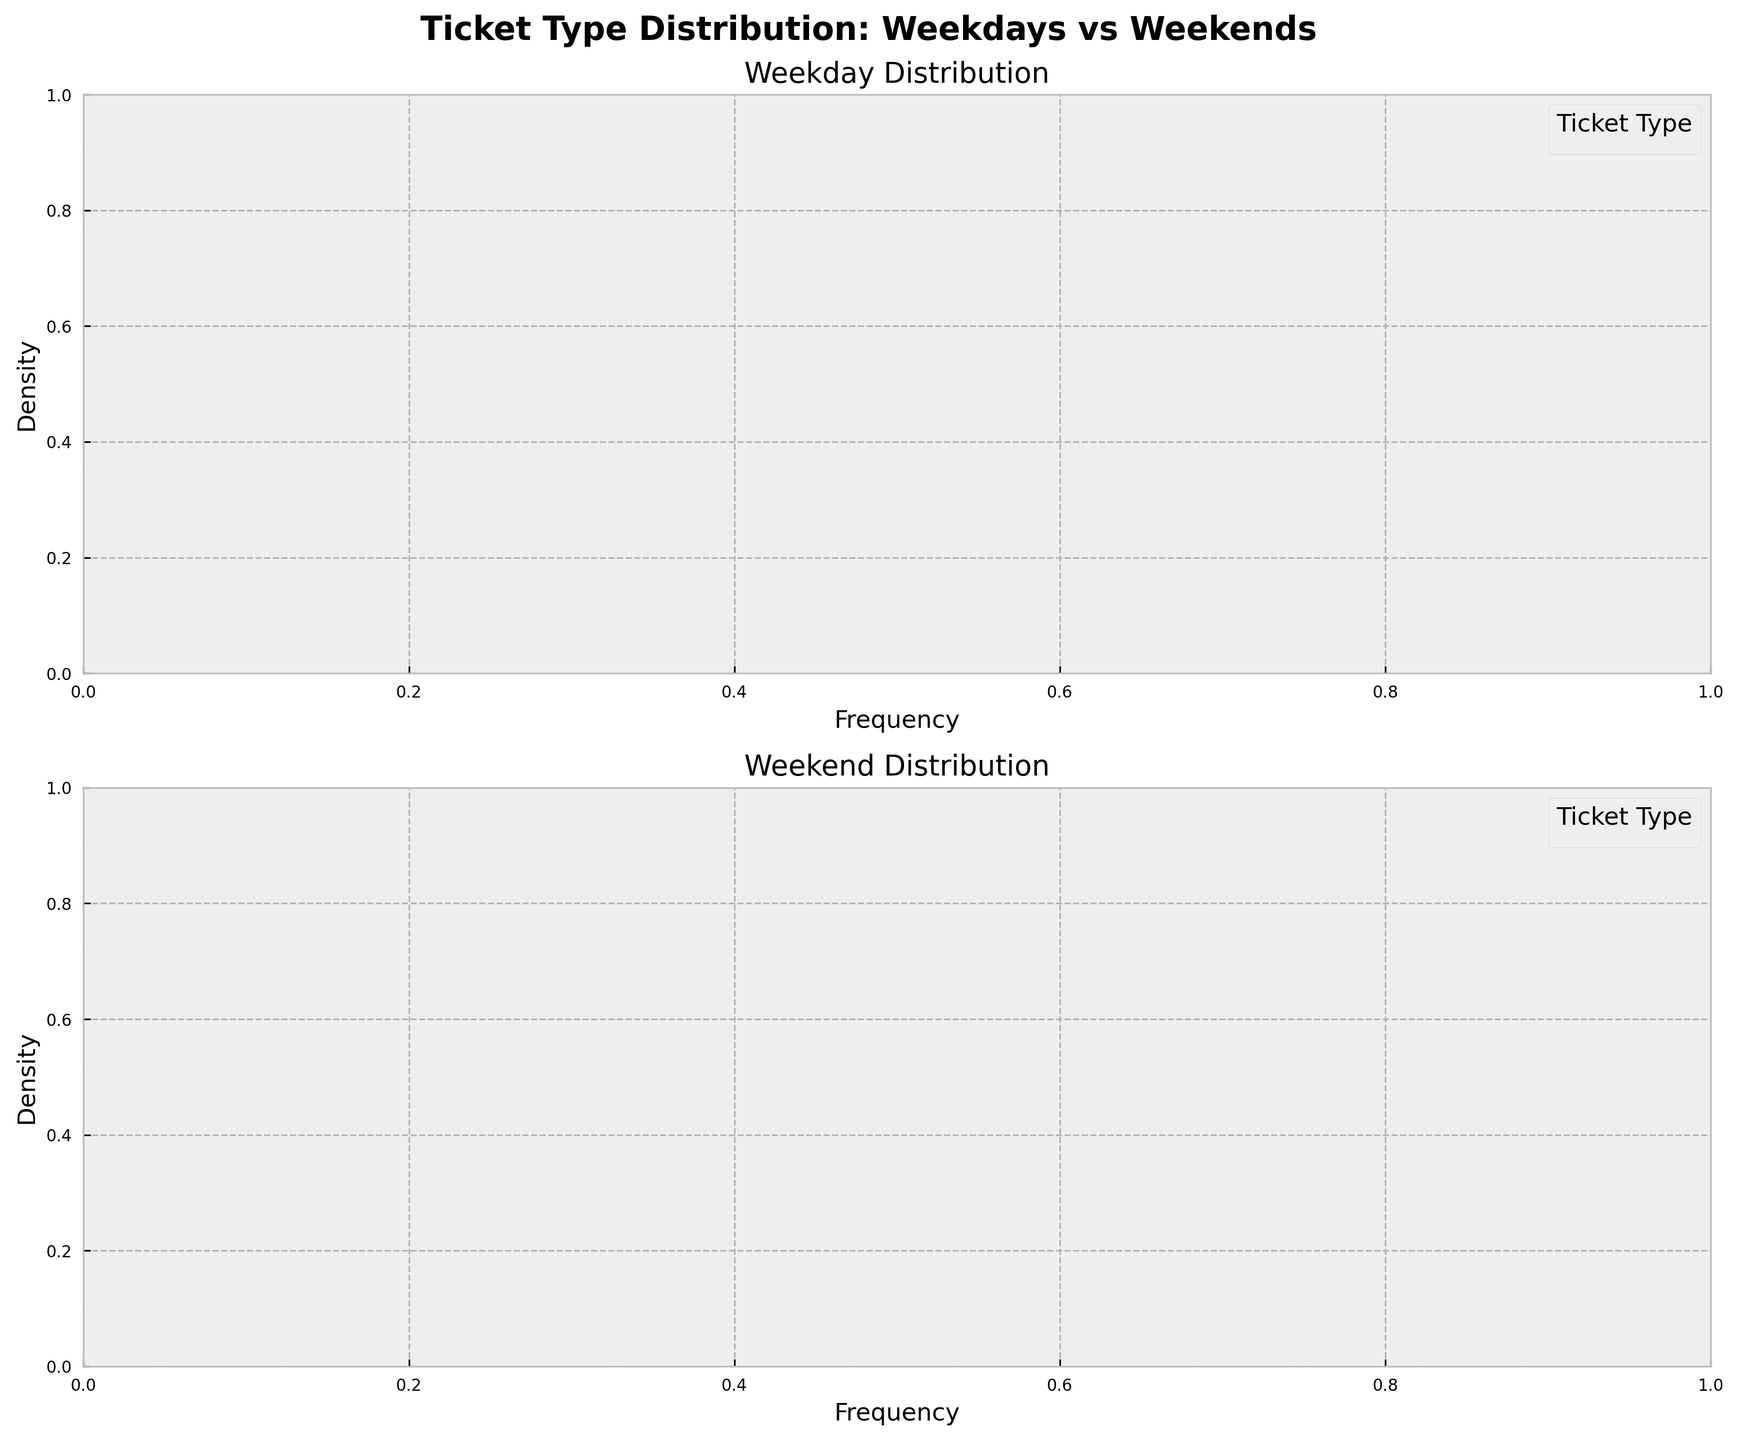What is the title of the figure? The title is displayed at the top of the figure. It reads 'Ticket Type Distribution: Weekdays vs Weekends'.
Answer: Ticket Type Distribution: Weekdays vs Weekends What is the x-axis label of the weekday subplot? The x-axis label is located below the x-axis in the weekday distribution subplot. It reads 'Frequency'.
Answer: Frequency Which ticket type shows the highest frequency density on weekends? By examining the density curves in the weekend subplot, we can see which ticket type has the highest peak. The 'Single' ticket type has the highest peak.
Answer: Single How does the density of Senior Citizen tickets compare between weekdays and weekends? Look at the density curves for 'Senior Citizen' tickets in both subplots. On weekends, the density for 'Senior Citizen' tickets is higher compared to weekdays.
Answer: Weekends have higher density Is the distribution of 'Off-Peak' ticket sales more spread out on weekdays or weekends? By comparing the width and shape of the 'Off-Peak' density curves in both subplots, we find that the weekend distribution is more spread out.
Answer: Weekends Which day shows a greater density for 'Student Pass' tickets? Compare the height of the 'Student Pass' ticket density curves in both subplots. The weekday subplot has a higher peak.
Answer: Weekdays How does the distribution of 'Family Day Pass' tickets differ between weekdays and weekends? Examine the shape and height of the 'Family Day Pass' density curves. On weekends, the density is higher and has a sharper peak compared to the wider and lower peak on weekdays.
Answer: Weekends have higher density and a sharper peak Which ticket type has a noticeably greater density on weekdays compared to weekends? By comparing all the density curves in both subplots, 'Return' tickets and 'Student Pass' have noticeably greater density on weekdays.
Answer: Return and Student Pass In terms of frequency distribution, which ticket type on weekends has a similar pattern to 'Single' tickets on weekdays? By comparing the shape and height of the curves, 'Off-Peak' tickets on weekends show a somewhat similar pattern to 'Single' tickets on weekdays.
Answer: Off-Peak 